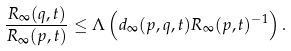Convert formula to latex. <formula><loc_0><loc_0><loc_500><loc_500>\frac { R _ { \infty } ( q , t ) } { R _ { \infty } ( p , t ) } \leq \Lambda \left ( d _ { \infty } ( p , q , t ) R _ { \infty } ( p , t ) ^ { - 1 } \right ) .</formula> 